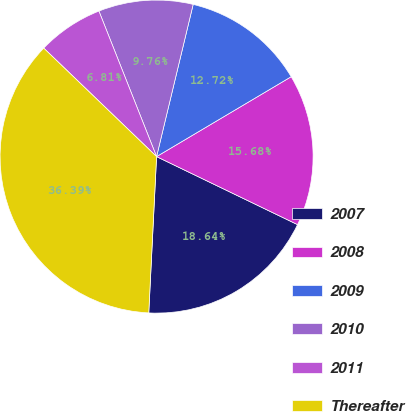Convert chart. <chart><loc_0><loc_0><loc_500><loc_500><pie_chart><fcel>2007<fcel>2008<fcel>2009<fcel>2010<fcel>2011<fcel>Thereafter<nl><fcel>18.64%<fcel>15.68%<fcel>12.72%<fcel>9.76%<fcel>6.81%<fcel>36.39%<nl></chart> 